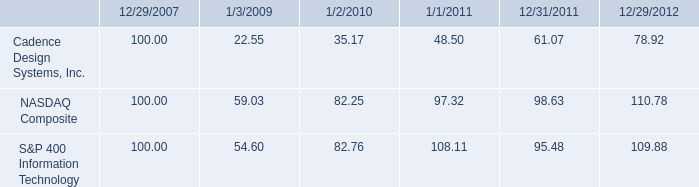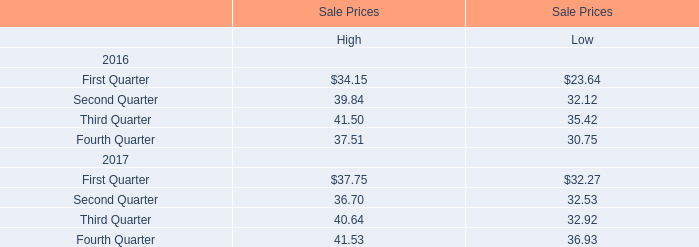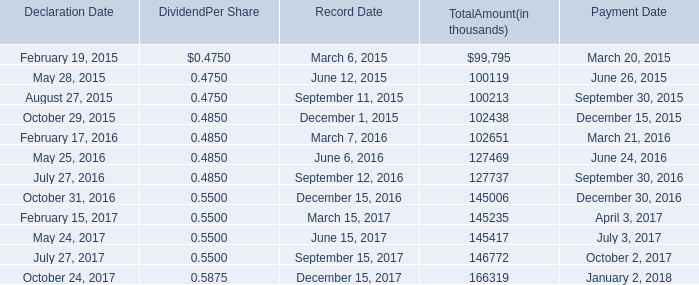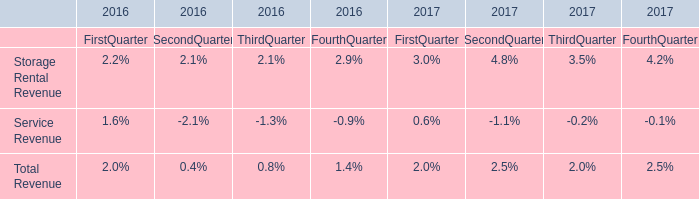As As the chart 2 shows,what is the sum of the Total Amount in the range of 100000 and 110000 in 2016? (in thousand) 
Answer: 102651. 